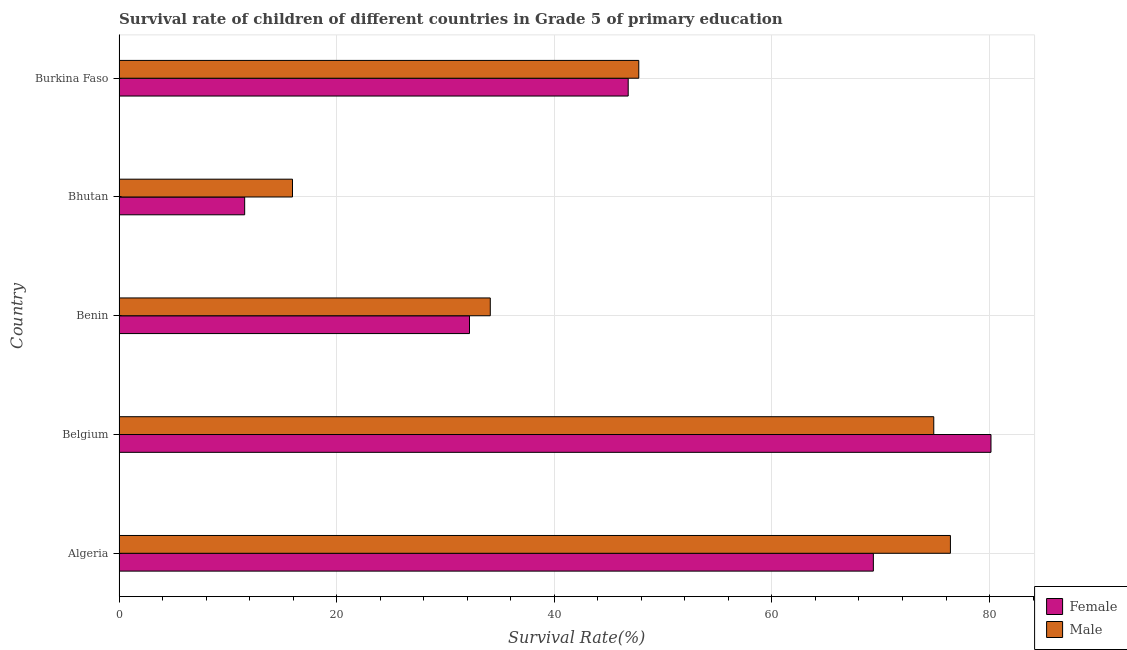How many different coloured bars are there?
Offer a terse response. 2. Are the number of bars per tick equal to the number of legend labels?
Ensure brevity in your answer.  Yes. Are the number of bars on each tick of the Y-axis equal?
Offer a very short reply. Yes. How many bars are there on the 3rd tick from the bottom?
Your response must be concise. 2. What is the label of the 5th group of bars from the top?
Make the answer very short. Algeria. What is the survival rate of female students in primary education in Belgium?
Ensure brevity in your answer.  80.14. Across all countries, what is the maximum survival rate of female students in primary education?
Your answer should be very brief. 80.14. Across all countries, what is the minimum survival rate of male students in primary education?
Your response must be concise. 15.94. In which country was the survival rate of female students in primary education minimum?
Your answer should be compact. Bhutan. What is the total survival rate of male students in primary education in the graph?
Make the answer very short. 249.11. What is the difference between the survival rate of female students in primary education in Algeria and that in Bhutan?
Offer a very short reply. 57.78. What is the difference between the survival rate of female students in primary education in Benin and the survival rate of male students in primary education in Burkina Faso?
Your response must be concise. -15.56. What is the average survival rate of male students in primary education per country?
Give a very brief answer. 49.82. What is the difference between the survival rate of male students in primary education and survival rate of female students in primary education in Belgium?
Provide a short and direct response. -5.26. What is the ratio of the survival rate of male students in primary education in Algeria to that in Burkina Faso?
Keep it short and to the point. 1.6. Is the difference between the survival rate of female students in primary education in Belgium and Burkina Faso greater than the difference between the survival rate of male students in primary education in Belgium and Burkina Faso?
Ensure brevity in your answer.  Yes. What is the difference between the highest and the second highest survival rate of female students in primary education?
Provide a succinct answer. 10.81. What is the difference between the highest and the lowest survival rate of female students in primary education?
Keep it short and to the point. 68.59. In how many countries, is the survival rate of female students in primary education greater than the average survival rate of female students in primary education taken over all countries?
Your answer should be very brief. 2. What does the 1st bar from the top in Benin represents?
Give a very brief answer. Male. How many bars are there?
Ensure brevity in your answer.  10. How many countries are there in the graph?
Give a very brief answer. 5. What is the difference between two consecutive major ticks on the X-axis?
Keep it short and to the point. 20. Does the graph contain any zero values?
Your answer should be compact. No. How many legend labels are there?
Provide a short and direct response. 2. What is the title of the graph?
Provide a short and direct response. Survival rate of children of different countries in Grade 5 of primary education. What is the label or title of the X-axis?
Provide a short and direct response. Survival Rate(%). What is the Survival Rate(%) of Female in Algeria?
Keep it short and to the point. 69.32. What is the Survival Rate(%) of Male in Algeria?
Your answer should be compact. 76.41. What is the Survival Rate(%) in Female in Belgium?
Your response must be concise. 80.14. What is the Survival Rate(%) in Male in Belgium?
Provide a succinct answer. 74.88. What is the Survival Rate(%) of Female in Benin?
Your answer should be compact. 32.21. What is the Survival Rate(%) of Male in Benin?
Offer a terse response. 34.12. What is the Survival Rate(%) of Female in Bhutan?
Your response must be concise. 11.54. What is the Survival Rate(%) of Male in Bhutan?
Your answer should be compact. 15.94. What is the Survival Rate(%) of Female in Burkina Faso?
Offer a very short reply. 46.79. What is the Survival Rate(%) in Male in Burkina Faso?
Give a very brief answer. 47.77. Across all countries, what is the maximum Survival Rate(%) of Female?
Provide a succinct answer. 80.14. Across all countries, what is the maximum Survival Rate(%) in Male?
Provide a succinct answer. 76.41. Across all countries, what is the minimum Survival Rate(%) in Female?
Make the answer very short. 11.54. Across all countries, what is the minimum Survival Rate(%) in Male?
Ensure brevity in your answer.  15.94. What is the total Survival Rate(%) of Female in the graph?
Offer a very short reply. 240.01. What is the total Survival Rate(%) of Male in the graph?
Keep it short and to the point. 249.11. What is the difference between the Survival Rate(%) of Female in Algeria and that in Belgium?
Your response must be concise. -10.81. What is the difference between the Survival Rate(%) in Male in Algeria and that in Belgium?
Offer a very short reply. 1.53. What is the difference between the Survival Rate(%) in Female in Algeria and that in Benin?
Your response must be concise. 37.12. What is the difference between the Survival Rate(%) of Male in Algeria and that in Benin?
Keep it short and to the point. 42.29. What is the difference between the Survival Rate(%) in Female in Algeria and that in Bhutan?
Keep it short and to the point. 57.78. What is the difference between the Survival Rate(%) of Male in Algeria and that in Bhutan?
Make the answer very short. 60.47. What is the difference between the Survival Rate(%) of Female in Algeria and that in Burkina Faso?
Provide a short and direct response. 22.53. What is the difference between the Survival Rate(%) in Male in Algeria and that in Burkina Faso?
Keep it short and to the point. 28.64. What is the difference between the Survival Rate(%) of Female in Belgium and that in Benin?
Your answer should be compact. 47.93. What is the difference between the Survival Rate(%) of Male in Belgium and that in Benin?
Your answer should be compact. 40.76. What is the difference between the Survival Rate(%) in Female in Belgium and that in Bhutan?
Offer a terse response. 68.59. What is the difference between the Survival Rate(%) in Male in Belgium and that in Bhutan?
Offer a very short reply. 58.94. What is the difference between the Survival Rate(%) of Female in Belgium and that in Burkina Faso?
Keep it short and to the point. 33.34. What is the difference between the Survival Rate(%) in Male in Belgium and that in Burkina Faso?
Offer a terse response. 27.11. What is the difference between the Survival Rate(%) in Female in Benin and that in Bhutan?
Keep it short and to the point. 20.66. What is the difference between the Survival Rate(%) of Male in Benin and that in Bhutan?
Provide a short and direct response. 18.18. What is the difference between the Survival Rate(%) in Female in Benin and that in Burkina Faso?
Provide a short and direct response. -14.59. What is the difference between the Survival Rate(%) of Male in Benin and that in Burkina Faso?
Give a very brief answer. -13.65. What is the difference between the Survival Rate(%) of Female in Bhutan and that in Burkina Faso?
Give a very brief answer. -35.25. What is the difference between the Survival Rate(%) in Male in Bhutan and that in Burkina Faso?
Your response must be concise. -31.83. What is the difference between the Survival Rate(%) in Female in Algeria and the Survival Rate(%) in Male in Belgium?
Provide a short and direct response. -5.55. What is the difference between the Survival Rate(%) in Female in Algeria and the Survival Rate(%) in Male in Benin?
Your answer should be compact. 35.21. What is the difference between the Survival Rate(%) in Female in Algeria and the Survival Rate(%) in Male in Bhutan?
Your answer should be compact. 53.38. What is the difference between the Survival Rate(%) of Female in Algeria and the Survival Rate(%) of Male in Burkina Faso?
Give a very brief answer. 21.56. What is the difference between the Survival Rate(%) of Female in Belgium and the Survival Rate(%) of Male in Benin?
Your response must be concise. 46.02. What is the difference between the Survival Rate(%) of Female in Belgium and the Survival Rate(%) of Male in Bhutan?
Your response must be concise. 64.19. What is the difference between the Survival Rate(%) in Female in Belgium and the Survival Rate(%) in Male in Burkina Faso?
Provide a succinct answer. 32.37. What is the difference between the Survival Rate(%) in Female in Benin and the Survival Rate(%) in Male in Bhutan?
Offer a very short reply. 16.27. What is the difference between the Survival Rate(%) of Female in Benin and the Survival Rate(%) of Male in Burkina Faso?
Your response must be concise. -15.56. What is the difference between the Survival Rate(%) in Female in Bhutan and the Survival Rate(%) in Male in Burkina Faso?
Your answer should be compact. -36.22. What is the average Survival Rate(%) of Female per country?
Make the answer very short. 48. What is the average Survival Rate(%) in Male per country?
Keep it short and to the point. 49.82. What is the difference between the Survival Rate(%) of Female and Survival Rate(%) of Male in Algeria?
Provide a succinct answer. -7.08. What is the difference between the Survival Rate(%) in Female and Survival Rate(%) in Male in Belgium?
Your answer should be compact. 5.26. What is the difference between the Survival Rate(%) in Female and Survival Rate(%) in Male in Benin?
Make the answer very short. -1.91. What is the difference between the Survival Rate(%) of Female and Survival Rate(%) of Male in Bhutan?
Your response must be concise. -4.4. What is the difference between the Survival Rate(%) in Female and Survival Rate(%) in Male in Burkina Faso?
Offer a very short reply. -0.97. What is the ratio of the Survival Rate(%) in Female in Algeria to that in Belgium?
Provide a succinct answer. 0.87. What is the ratio of the Survival Rate(%) in Male in Algeria to that in Belgium?
Keep it short and to the point. 1.02. What is the ratio of the Survival Rate(%) in Female in Algeria to that in Benin?
Offer a very short reply. 2.15. What is the ratio of the Survival Rate(%) in Male in Algeria to that in Benin?
Keep it short and to the point. 2.24. What is the ratio of the Survival Rate(%) of Female in Algeria to that in Bhutan?
Keep it short and to the point. 6. What is the ratio of the Survival Rate(%) of Male in Algeria to that in Bhutan?
Your answer should be very brief. 4.79. What is the ratio of the Survival Rate(%) of Female in Algeria to that in Burkina Faso?
Provide a short and direct response. 1.48. What is the ratio of the Survival Rate(%) in Male in Algeria to that in Burkina Faso?
Your answer should be very brief. 1.6. What is the ratio of the Survival Rate(%) in Female in Belgium to that in Benin?
Your response must be concise. 2.49. What is the ratio of the Survival Rate(%) of Male in Belgium to that in Benin?
Ensure brevity in your answer.  2.19. What is the ratio of the Survival Rate(%) of Female in Belgium to that in Bhutan?
Your response must be concise. 6.94. What is the ratio of the Survival Rate(%) of Male in Belgium to that in Bhutan?
Provide a short and direct response. 4.7. What is the ratio of the Survival Rate(%) in Female in Belgium to that in Burkina Faso?
Give a very brief answer. 1.71. What is the ratio of the Survival Rate(%) of Male in Belgium to that in Burkina Faso?
Keep it short and to the point. 1.57. What is the ratio of the Survival Rate(%) of Female in Benin to that in Bhutan?
Offer a terse response. 2.79. What is the ratio of the Survival Rate(%) in Male in Benin to that in Bhutan?
Offer a terse response. 2.14. What is the ratio of the Survival Rate(%) in Female in Benin to that in Burkina Faso?
Offer a very short reply. 0.69. What is the ratio of the Survival Rate(%) in Male in Benin to that in Burkina Faso?
Give a very brief answer. 0.71. What is the ratio of the Survival Rate(%) of Female in Bhutan to that in Burkina Faso?
Ensure brevity in your answer.  0.25. What is the ratio of the Survival Rate(%) in Male in Bhutan to that in Burkina Faso?
Provide a succinct answer. 0.33. What is the difference between the highest and the second highest Survival Rate(%) in Female?
Offer a terse response. 10.81. What is the difference between the highest and the second highest Survival Rate(%) of Male?
Provide a succinct answer. 1.53. What is the difference between the highest and the lowest Survival Rate(%) in Female?
Offer a very short reply. 68.59. What is the difference between the highest and the lowest Survival Rate(%) of Male?
Offer a terse response. 60.47. 